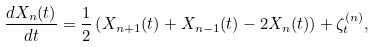<formula> <loc_0><loc_0><loc_500><loc_500>\frac { d X _ { n } ( t ) } { d t } = \frac { 1 } { 2 } \left ( X _ { n + 1 } ( t ) + X _ { n - 1 } ( t ) - 2 X _ { n } ( t ) \right ) + \zeta _ { t } ^ { ( n ) } ,</formula> 